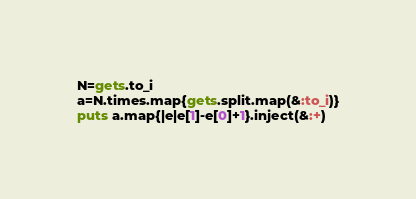<code> <loc_0><loc_0><loc_500><loc_500><_Ruby_>N=gets.to_i
a=N.times.map{gets.split.map(&:to_i)}
puts a.map{|e|e[1]-e[0]+1}.inject(&:+)</code> 